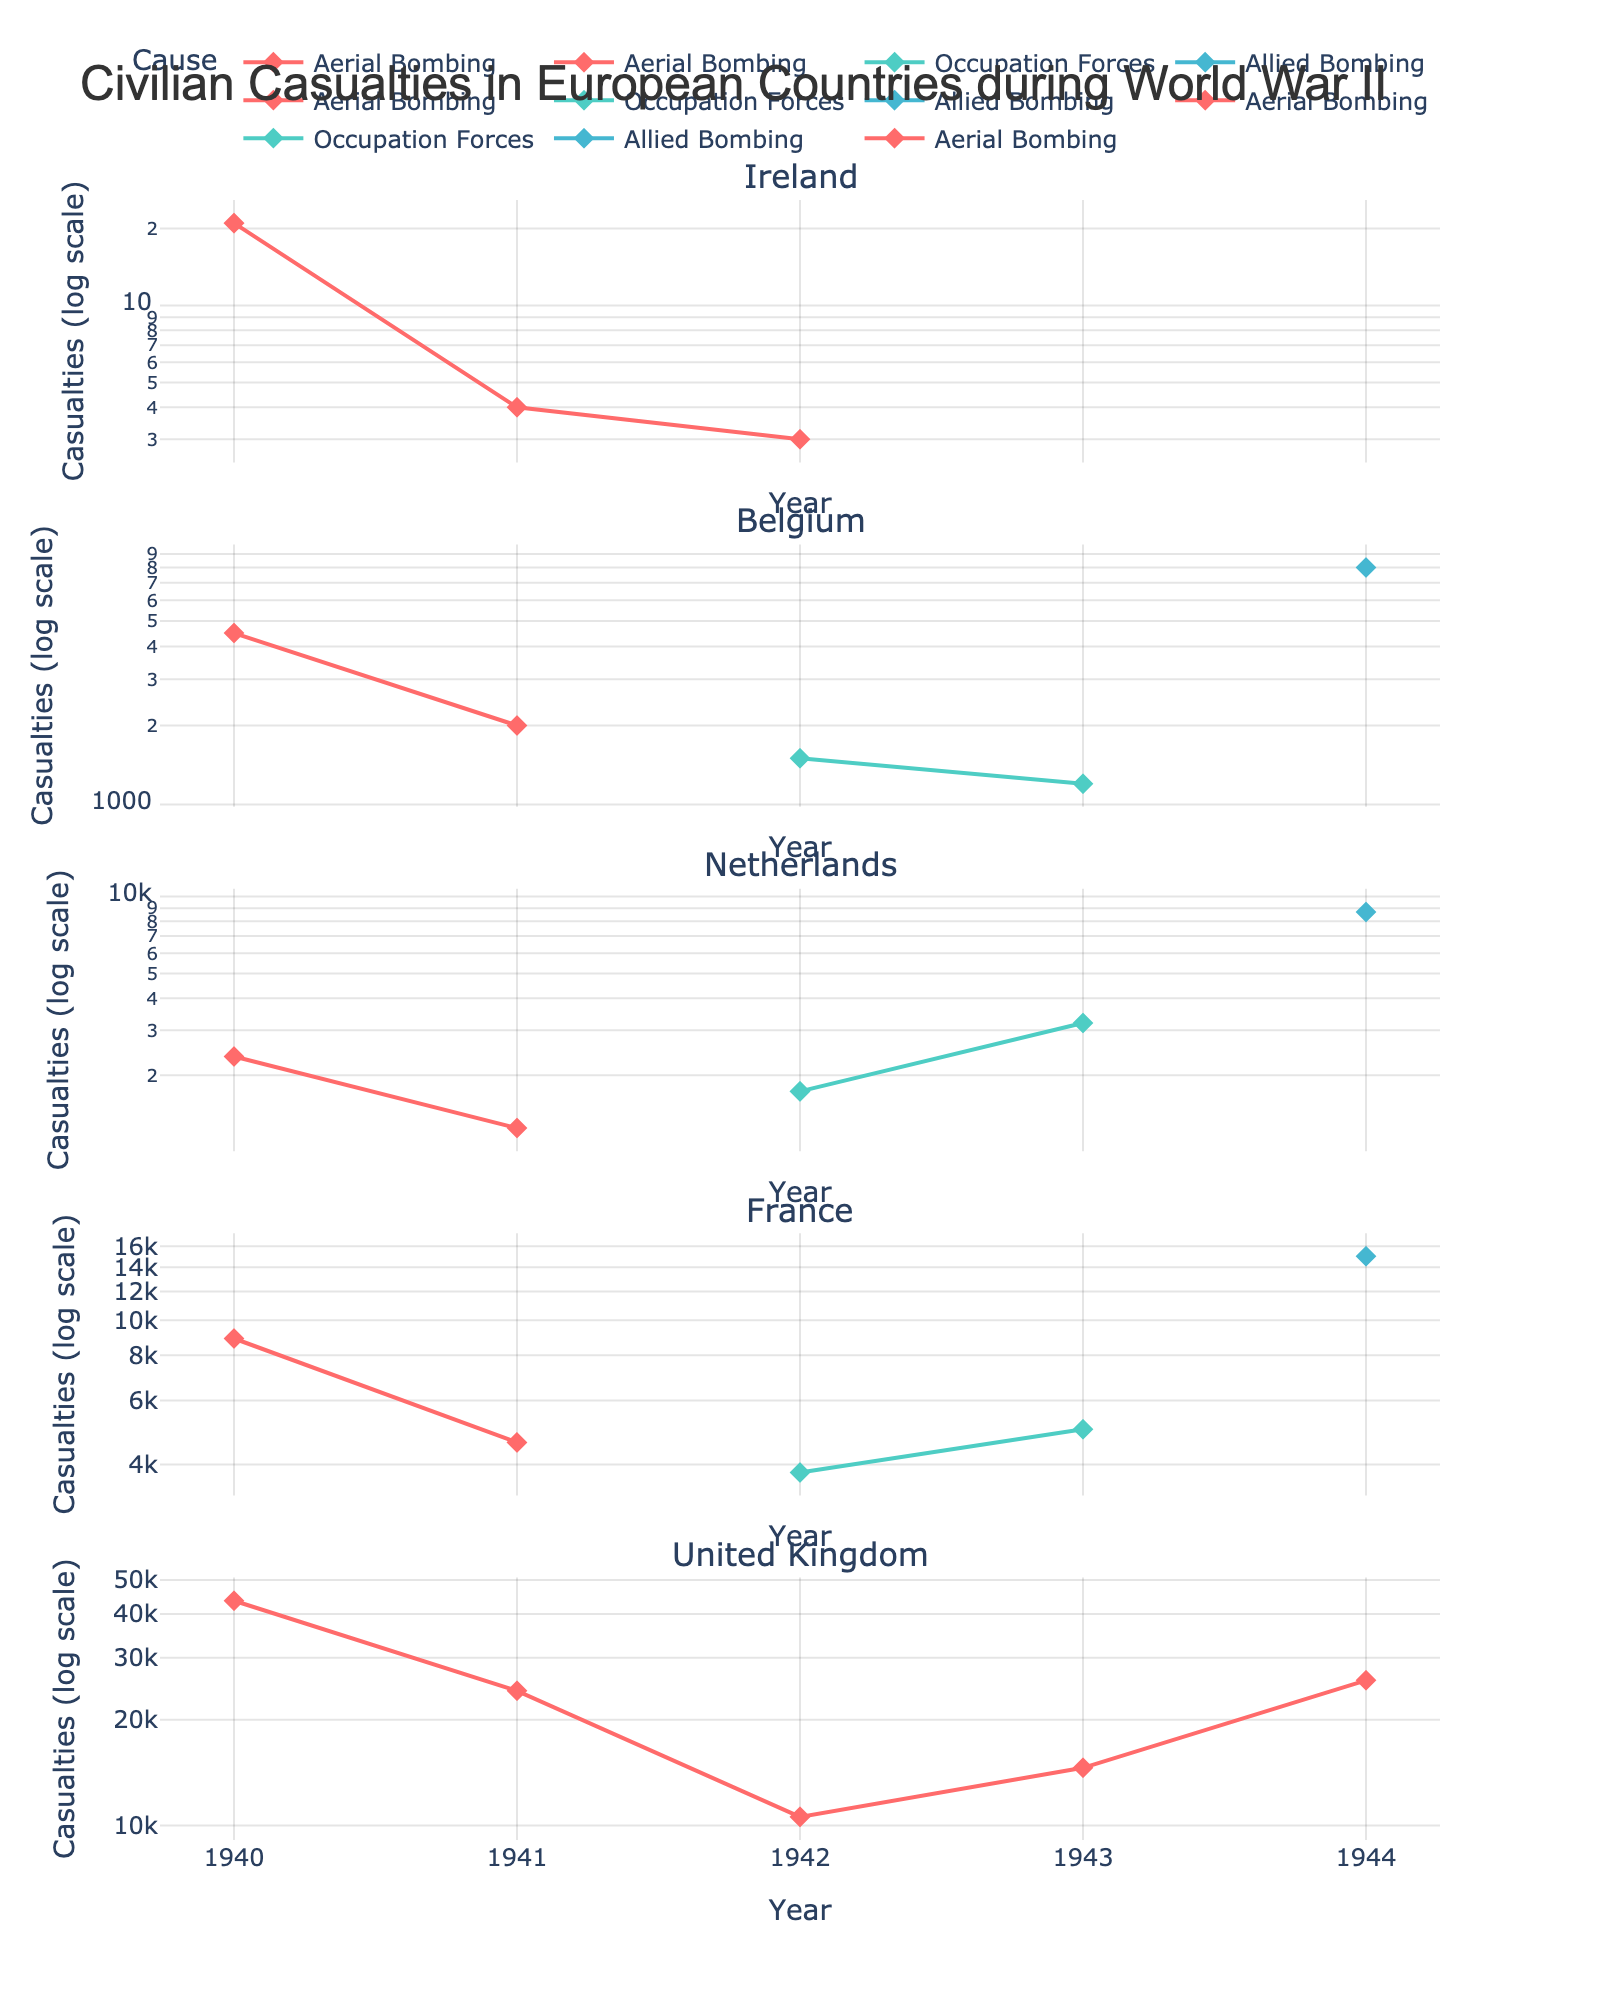Which country experienced the highest number of casualties in a single year and cause combination? To answer this, we need to identify the highest peak in any subplot. The United Kingdom's 1940 'Aerial Bombing' has the highest number, with 43,625 casualties.
Answer: United Kingdom In which year did France experience the most number of civilian casualties and what was the cause? By scanning the France subplot, the peak is in 1944 with 'Allied Bombing' causing 15,000 casualties.
Answer: 1944, Allied Bombing How do the casualties in Ireland due to aerial bombing in 1940 compare with those in Netherlands for the same cause and year? Locate Ireland's and Netherlands' subplots for the year 1940 under the 'Aerial Bombing' category. Ireland had 21 casualties, while Netherlands had 2,367. So, Netherlands had much higher casualties.
Answer: 21 (Ireland), 2,367 (Netherlands) What is the general trend in casualties for Belgium from 1940 to 1944? Looking at Belgium’s subplot, there's an initial dip from high casualties in 1940 (4,500) to fewer casualties in following years, then a spike in 1944 (8,000) due to 'Allied Bombing'.
Answer: Decreasing then increasing Which country saw an increase in casualties due to 'Occupation Forces' from 1940 to 1943? Check each country's subplot for the 'Occupation Forces' from 1940 to 1943. Both Belgium and Netherlands show an increase, but France also shows a consistent increase.
Answer: France In terms of 'Aerial Bombing', which country had the smallest number of civilian casualties in all recorded years? Compare the 'Aerial Bombing' data point across all countries. Ireland had the fewest casualties, with numbers significantly lower than others.
Answer: Ireland Between the years 1940 and 1944, in which year did the United Kingdom experience the lowest number of casualties due to aerial bombing? Check United Kingdom’s subplot across the years for 'Aerial Bombing'. The year with the lowest is 1942 with 10,578 casualties.
Answer: 1942 What was the primary cause of civilian casualties in Belgium in 1944? Look at Belgium’s subplot for 1944 and observe which line corresponds to the peak. It is 'Allied Bombing' with 8,000 casualties.
Answer: Allied Bombing 